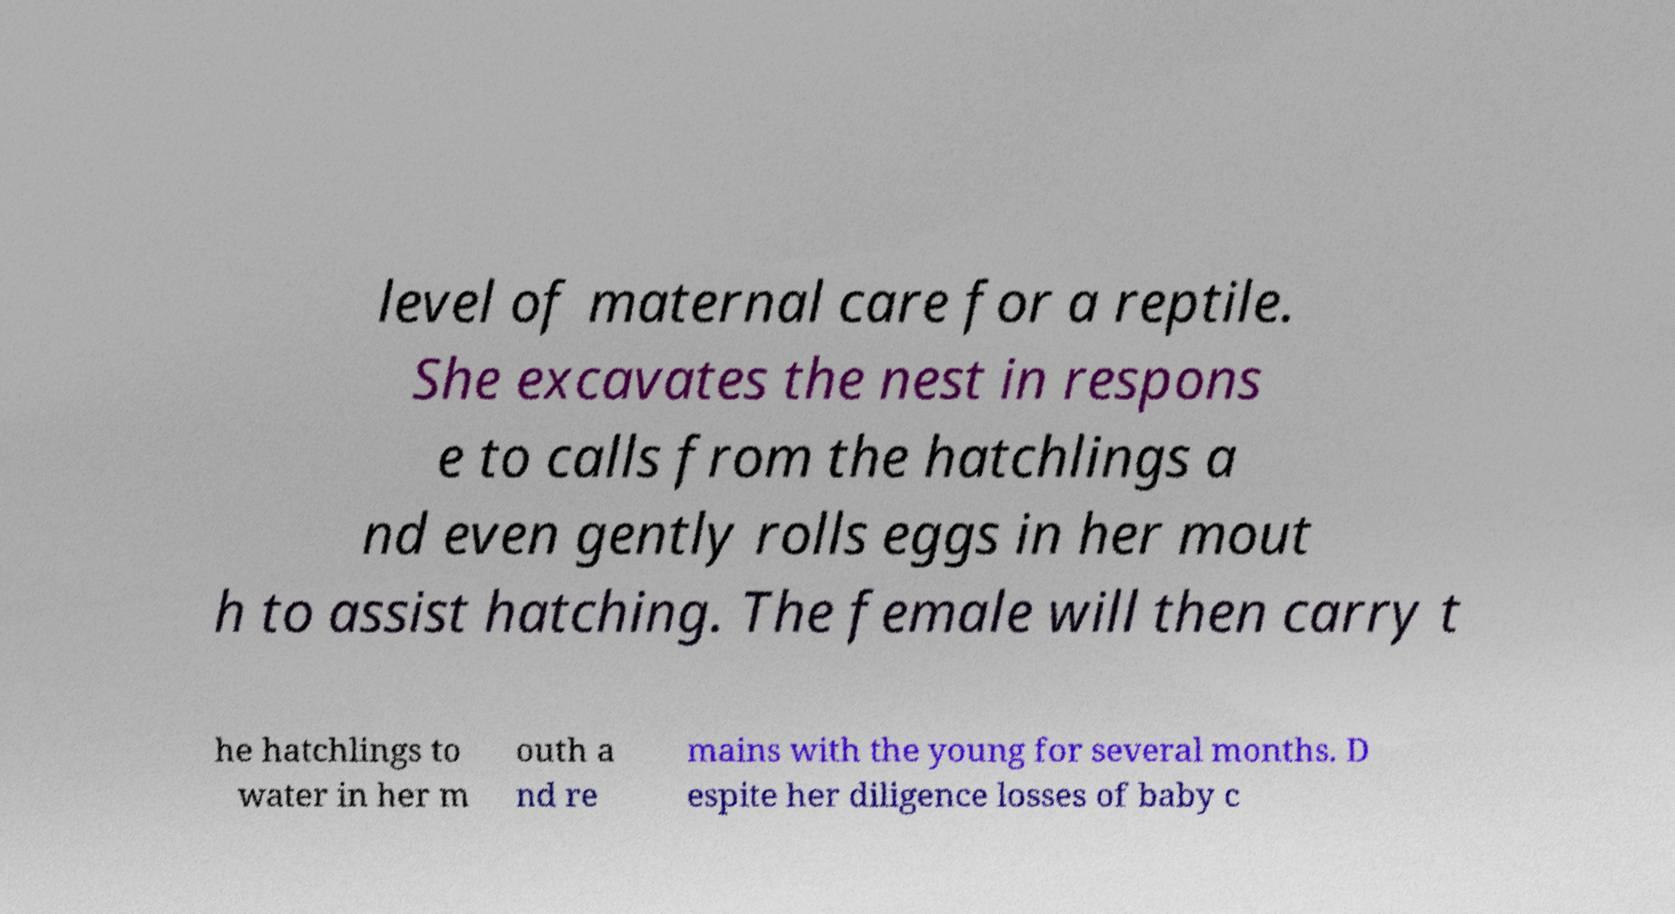Could you extract and type out the text from this image? level of maternal care for a reptile. She excavates the nest in respons e to calls from the hatchlings a nd even gently rolls eggs in her mout h to assist hatching. The female will then carry t he hatchlings to water in her m outh a nd re mains with the young for several months. D espite her diligence losses of baby c 